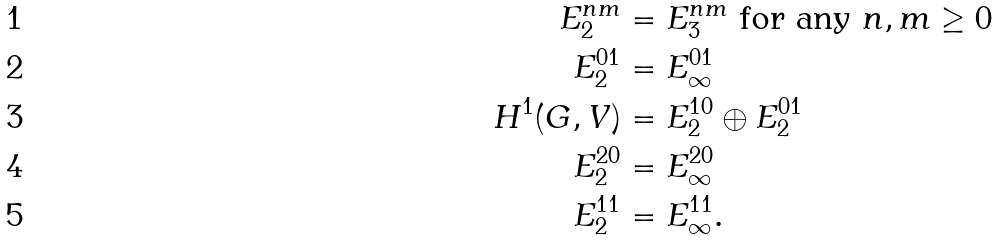Convert formula to latex. <formula><loc_0><loc_0><loc_500><loc_500>E _ { 2 } ^ { n m } & = E _ { 3 } ^ { n m } \text { for any } n , m \geq 0 \\ E _ { 2 } ^ { 0 1 } & = E _ { \infty } ^ { 0 1 } \\ H ^ { 1 } ( G , V ) & = E _ { 2 } ^ { 1 0 } \oplus E _ { 2 } ^ { 0 1 } \\ E _ { 2 } ^ { 2 0 } & = E _ { \infty } ^ { 2 0 } \\ E _ { 2 } ^ { 1 1 } & = E _ { \infty } ^ { 1 1 } .</formula> 